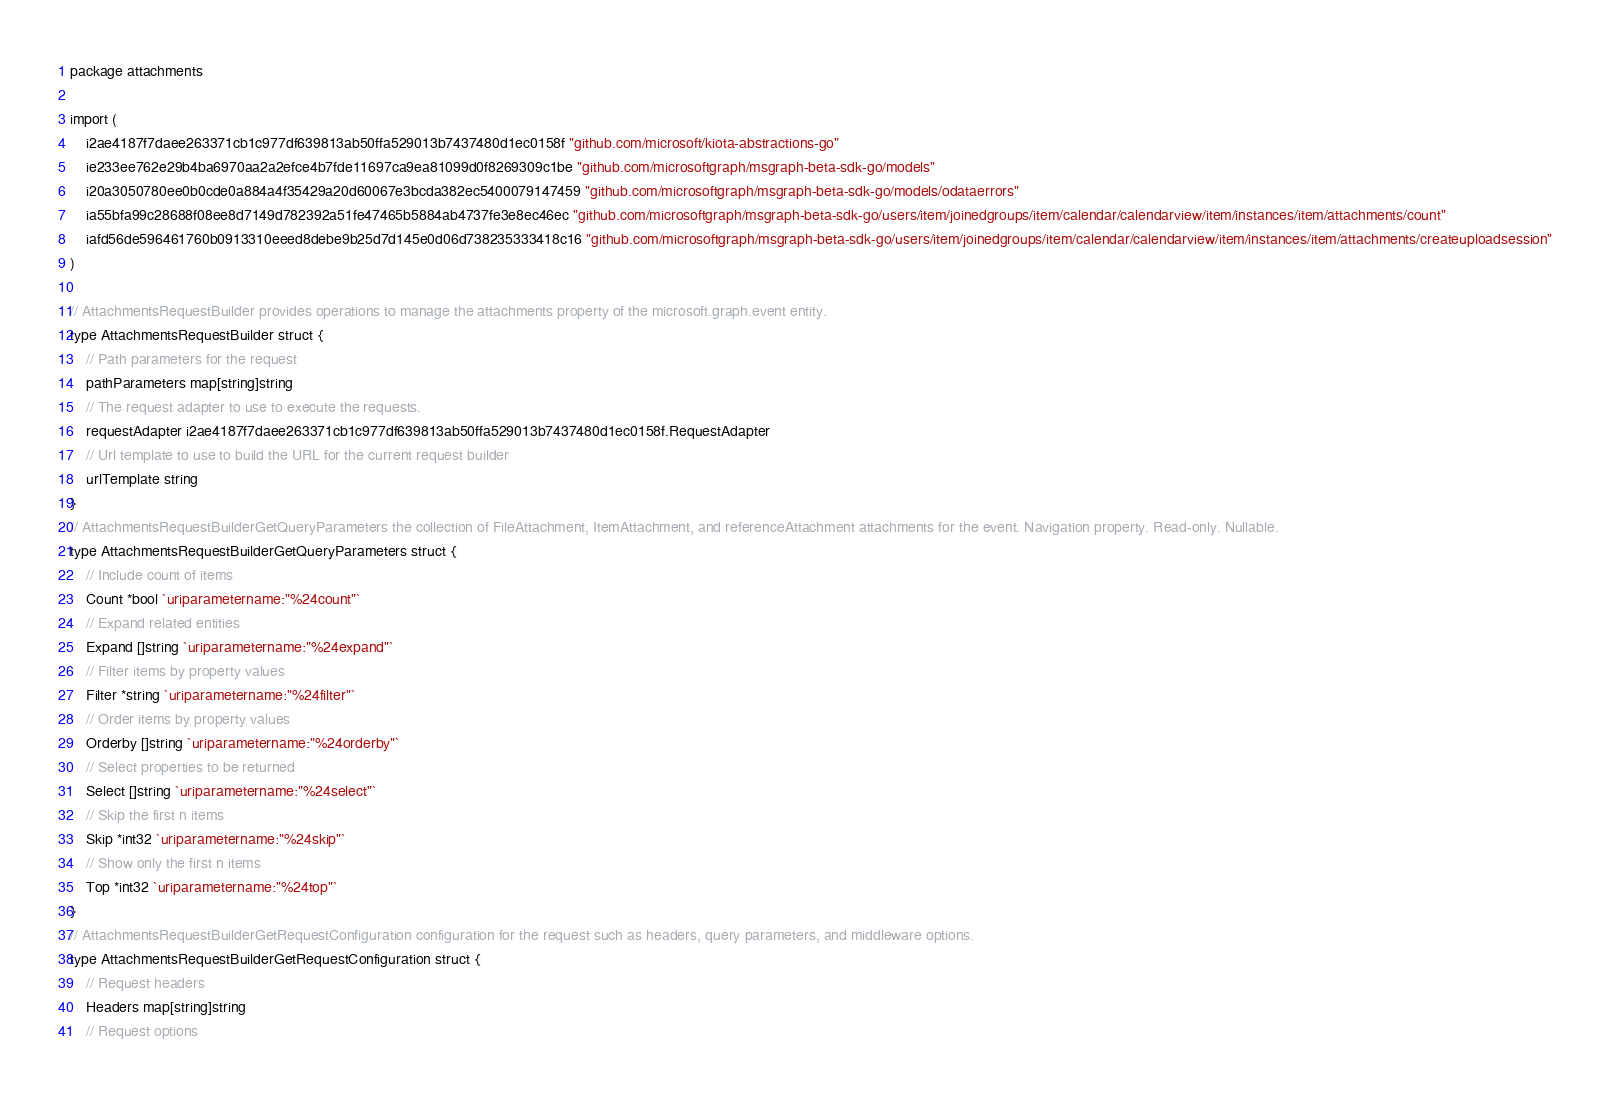<code> <loc_0><loc_0><loc_500><loc_500><_Go_>package attachments

import (
    i2ae4187f7daee263371cb1c977df639813ab50ffa529013b7437480d1ec0158f "github.com/microsoft/kiota-abstractions-go"
    ie233ee762e29b4ba6970aa2a2efce4b7fde11697ca9ea81099d0f8269309c1be "github.com/microsoftgraph/msgraph-beta-sdk-go/models"
    i20a3050780ee0b0cde0a884a4f35429a20d60067e3bcda382ec5400079147459 "github.com/microsoftgraph/msgraph-beta-sdk-go/models/odataerrors"
    ia55bfa99c28688f08ee8d7149d782392a51fe47465b5884ab4737fe3e8ec46ec "github.com/microsoftgraph/msgraph-beta-sdk-go/users/item/joinedgroups/item/calendar/calendarview/item/instances/item/attachments/count"
    iafd56de596461760b0913310eeed8debe9b25d7d145e0d06d738235333418c16 "github.com/microsoftgraph/msgraph-beta-sdk-go/users/item/joinedgroups/item/calendar/calendarview/item/instances/item/attachments/createuploadsession"
)

// AttachmentsRequestBuilder provides operations to manage the attachments property of the microsoft.graph.event entity.
type AttachmentsRequestBuilder struct {
    // Path parameters for the request
    pathParameters map[string]string
    // The request adapter to use to execute the requests.
    requestAdapter i2ae4187f7daee263371cb1c977df639813ab50ffa529013b7437480d1ec0158f.RequestAdapter
    // Url template to use to build the URL for the current request builder
    urlTemplate string
}
// AttachmentsRequestBuilderGetQueryParameters the collection of FileAttachment, ItemAttachment, and referenceAttachment attachments for the event. Navigation property. Read-only. Nullable.
type AttachmentsRequestBuilderGetQueryParameters struct {
    // Include count of items
    Count *bool `uriparametername:"%24count"`
    // Expand related entities
    Expand []string `uriparametername:"%24expand"`
    // Filter items by property values
    Filter *string `uriparametername:"%24filter"`
    // Order items by property values
    Orderby []string `uriparametername:"%24orderby"`
    // Select properties to be returned
    Select []string `uriparametername:"%24select"`
    // Skip the first n items
    Skip *int32 `uriparametername:"%24skip"`
    // Show only the first n items
    Top *int32 `uriparametername:"%24top"`
}
// AttachmentsRequestBuilderGetRequestConfiguration configuration for the request such as headers, query parameters, and middleware options.
type AttachmentsRequestBuilderGetRequestConfiguration struct {
    // Request headers
    Headers map[string]string
    // Request options</code> 